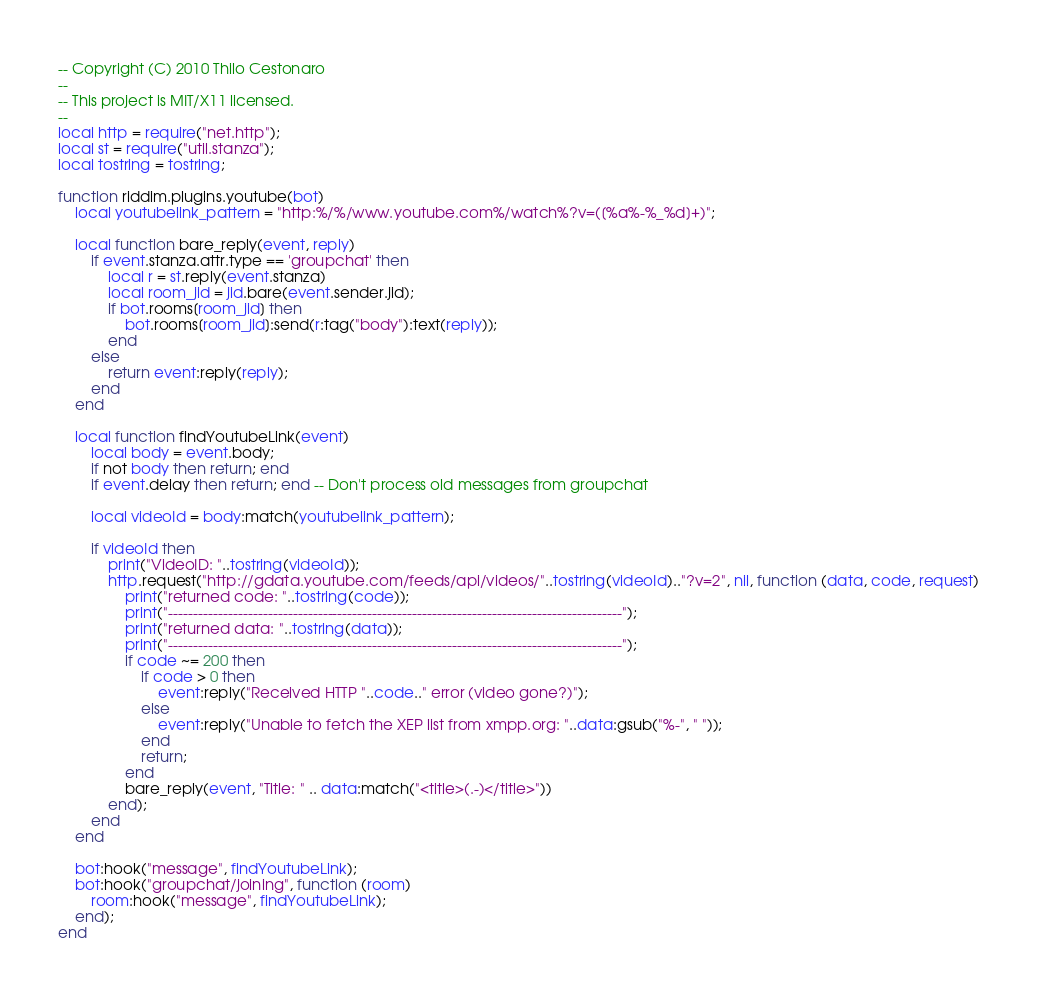<code> <loc_0><loc_0><loc_500><loc_500><_Lua_>-- Copyright (C) 2010 Thilo Cestonaro
-- 
-- This project is MIT/X11 licensed.
--
local http = require("net.http");
local st = require("util.stanza");
local tostring = tostring;

function riddim.plugins.youtube(bot)
	local youtubelink_pattern = "http:%/%/www.youtube.com%/watch%?v=([%a%-%_%d]+)";

	local function bare_reply(event, reply)
		if event.stanza.attr.type == 'groupchat' then
			local r = st.reply(event.stanza)
			local room_jid = jid.bare(event.sender.jid);
			if bot.rooms[room_jid] then
				bot.rooms[room_jid]:send(r:tag("body"):text(reply));
			end
		else
			return event:reply(reply);
		end
	end

	local function findYoutubeLink(event)
		local body = event.body;
		if not body then return; end
		if event.delay then return; end -- Don't process old messages from groupchat

		local videoId = body:match(youtubelink_pattern);

		if videoId then
			print("VideoID: "..tostring(videoId));
			http.request("http://gdata.youtube.com/feeds/api/videos/"..tostring(videoId).."?v=2", nil, function (data, code, request)
				print("returned code: "..tostring(code));
				print("-------------------------------------------------------------------------------------------");
				print("returned data: "..tostring(data));
				print("-------------------------------------------------------------------------------------------");
				if code ~= 200 then
					if code > 0 then
						event:reply("Received HTTP "..code.." error (video gone?)");
					else
						event:reply("Unable to fetch the XEP list from xmpp.org: "..data:gsub("%-", " "));
					end
					return;
				end
				bare_reply(event, "Title: " .. data:match("<title>(.-)</title>"))
			end);
		end
	end

	bot:hook("message", findYoutubeLink);
	bot:hook("groupchat/joining", function (room)
		room:hook("message", findYoutubeLink);
	end);
end

</code> 